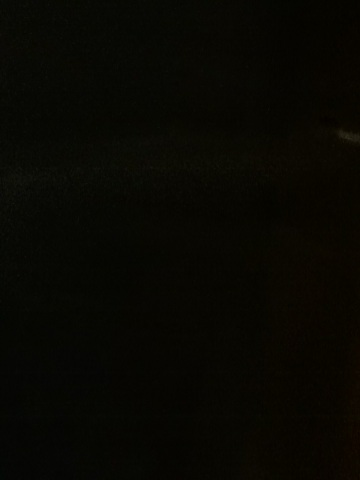What is the color of that phone? Due to the extremely low lighting in the image, it is not possible to determine the presence or color of a phone. For a more precise answer, please provide a clearer image with adequate lighting. 